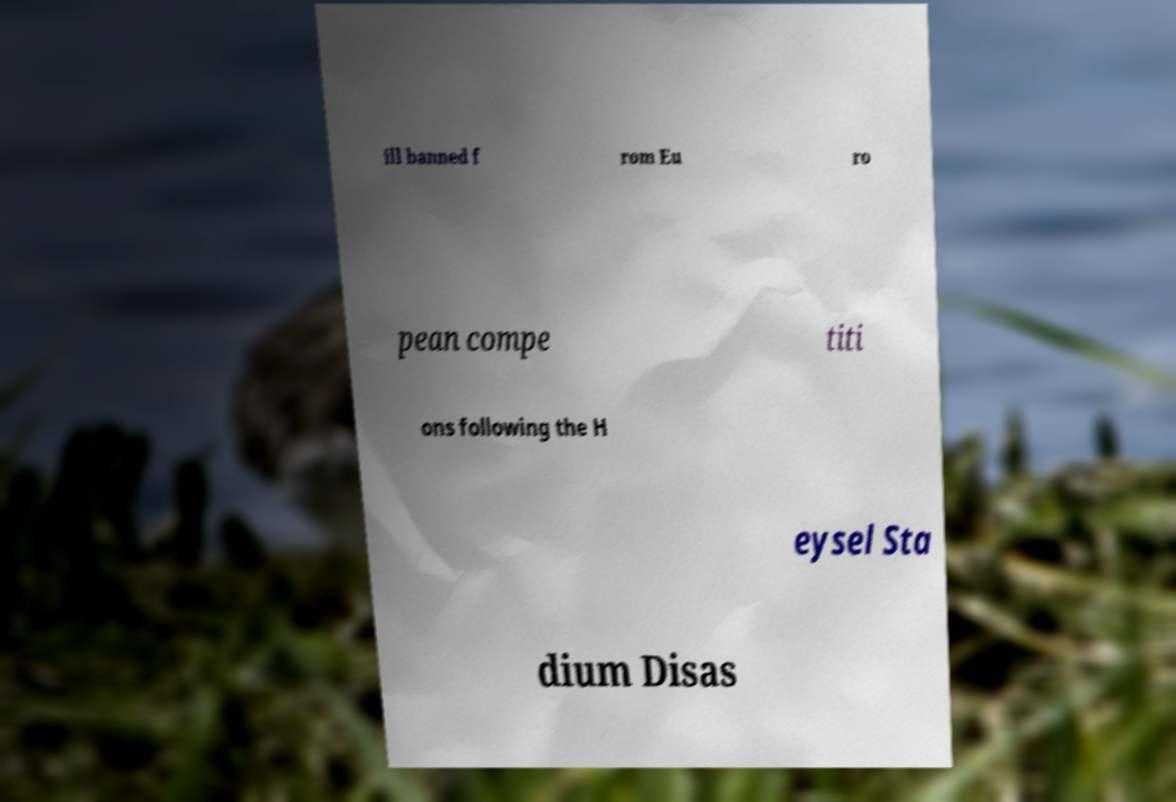Could you extract and type out the text from this image? ill banned f rom Eu ro pean compe titi ons following the H eysel Sta dium Disas 